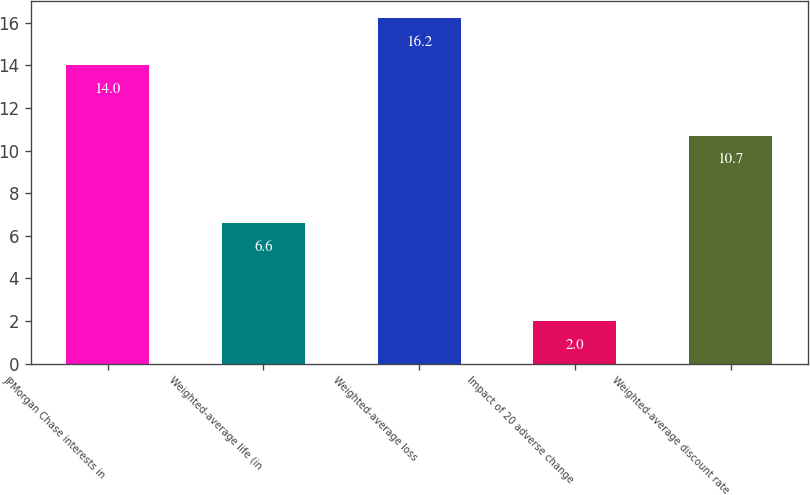Convert chart. <chart><loc_0><loc_0><loc_500><loc_500><bar_chart><fcel>JPMorgan Chase interests in<fcel>Weighted-average life (in<fcel>Weighted-average loss<fcel>Impact of 20 adverse change<fcel>Weighted-average discount rate<nl><fcel>14<fcel>6.6<fcel>16.2<fcel>2<fcel>10.7<nl></chart> 